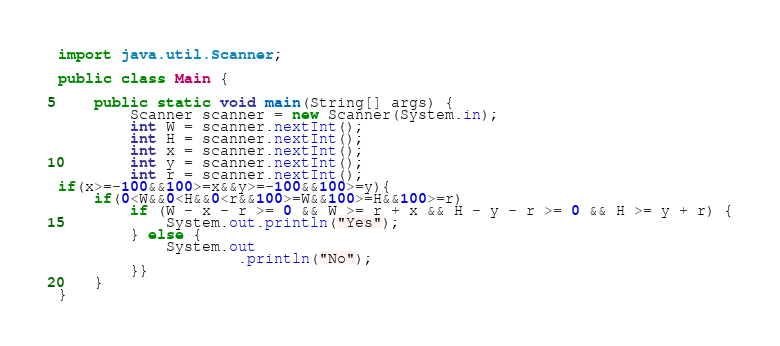<code> <loc_0><loc_0><loc_500><loc_500><_Java_>import java.util.Scanner;

public class Main {

    public static void main(String[] args) {
        Scanner scanner = new Scanner(System.in);
        int W = scanner.nextInt();
        int H = scanner.nextInt();
        int x = scanner.nextInt();
        int y = scanner.nextInt();
        int r = scanner.nextInt();
if(x>=-100&&100>=x&&y>=-100&&100>=y){
    if(0<W&&0<H&&0<r&&100>=W&&100>=H&&100>=r)
        if (W - x - r >= 0 && W >= r + x && H - y - r >= 0 && H >= y + r) {
            System.out.println("Yes");
        } else {
            System.out
                    .println("No");
        }}
    }
}</code> 